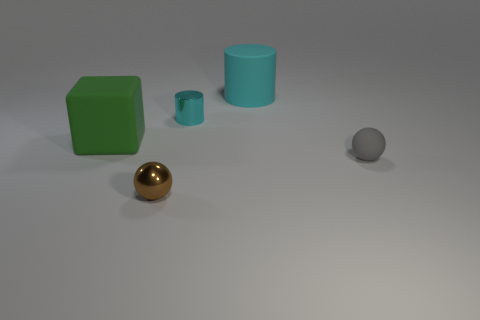Is there a thing of the same color as the large cylinder?
Your answer should be very brief. Yes. Are there any tiny yellow things made of the same material as the green block?
Offer a very short reply. No. There is a large matte thing that is in front of the cyan shiny cylinder; what shape is it?
Offer a terse response. Cube. There is a tiny thing behind the matte ball; does it have the same color as the large cylinder?
Offer a terse response. Yes. Is the number of small gray matte objects that are on the right side of the large cube less than the number of large yellow things?
Offer a terse response. No. What color is the tiny sphere that is the same material as the small cyan cylinder?
Offer a terse response. Brown. How big is the cylinder behind the cyan shiny thing?
Make the answer very short. Large. Do the block and the tiny gray thing have the same material?
Give a very brief answer. Yes. There is a cyan object behind the cylinder that is in front of the large rubber cylinder; is there a green block on the left side of it?
Give a very brief answer. Yes. The shiny cylinder has what color?
Keep it short and to the point. Cyan. 